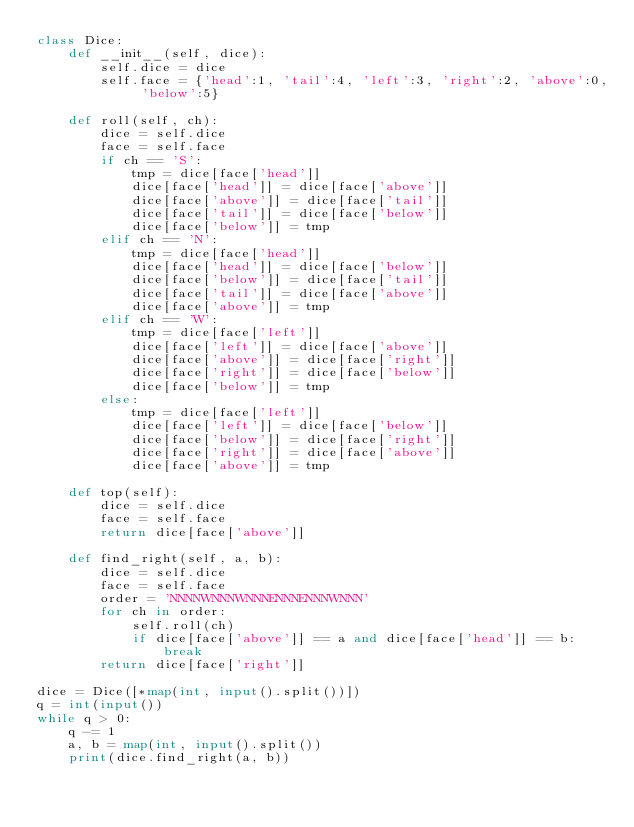Convert code to text. <code><loc_0><loc_0><loc_500><loc_500><_Python_>class Dice:
    def __init__(self, dice):
        self.dice = dice
        self.face = {'head':1, 'tail':4, 'left':3, 'right':2, 'above':0, 'below':5}
    
    def roll(self, ch):
        dice = self.dice
        face = self.face
        if ch == 'S':
            tmp = dice[face['head']]
            dice[face['head']] = dice[face['above']]
            dice[face['above']] = dice[face['tail']]
            dice[face['tail']] = dice[face['below']]
            dice[face['below']] = tmp
        elif ch == 'N':
            tmp = dice[face['head']]
            dice[face['head']] = dice[face['below']]
            dice[face['below']] = dice[face['tail']]
            dice[face['tail']] = dice[face['above']]
            dice[face['above']] = tmp
        elif ch == 'W':
            tmp = dice[face['left']]
            dice[face['left']] = dice[face['above']]
            dice[face['above']] = dice[face['right']]
            dice[face['right']] = dice[face['below']]
            dice[face['below']] = tmp
        else:
            tmp = dice[face['left']]
            dice[face['left']] = dice[face['below']]
            dice[face['below']] = dice[face['right']]
            dice[face['right']] = dice[face['above']]
            dice[face['above']] = tmp

    def top(self):
        dice = self.dice
        face = self.face
        return dice[face['above']]
    
    def find_right(self, a, b):
        dice = self.dice
        face = self.face
        order = 'NNNNWNNNWNNNENNNENNNWNNN'
        for ch in order:
            self.roll(ch)
            if dice[face['above']] == a and dice[face['head']] == b:
                break
        return dice[face['right']]

dice = Dice([*map(int, input().split())])
q = int(input())
while q > 0:
    q -= 1
    a, b = map(int, input().split())
    print(dice.find_right(a, b))
</code> 